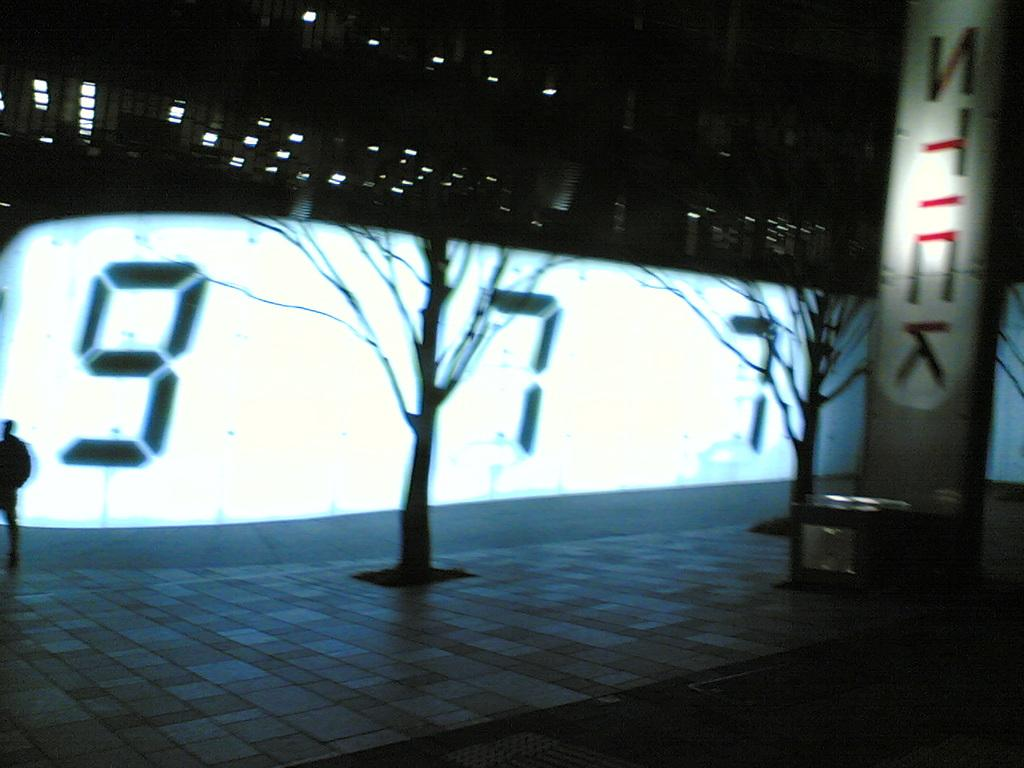What type of vegetation is present in the image? There are dry trees in the image. What can be seen in the middle of the image? There is a screen in the middle of the image. What is located on the right side of the image? There is a board on the right side of the image. Can you tell me how many jewels are on the board in the image? There is no mention of jewels in the image; the board is the only object mentioned on the right side of the image. Is there a woman sleeping on the screen in the image? There is no woman or any indication of sleep in the image; the screen is the only object mentioned in the middle of the image. 